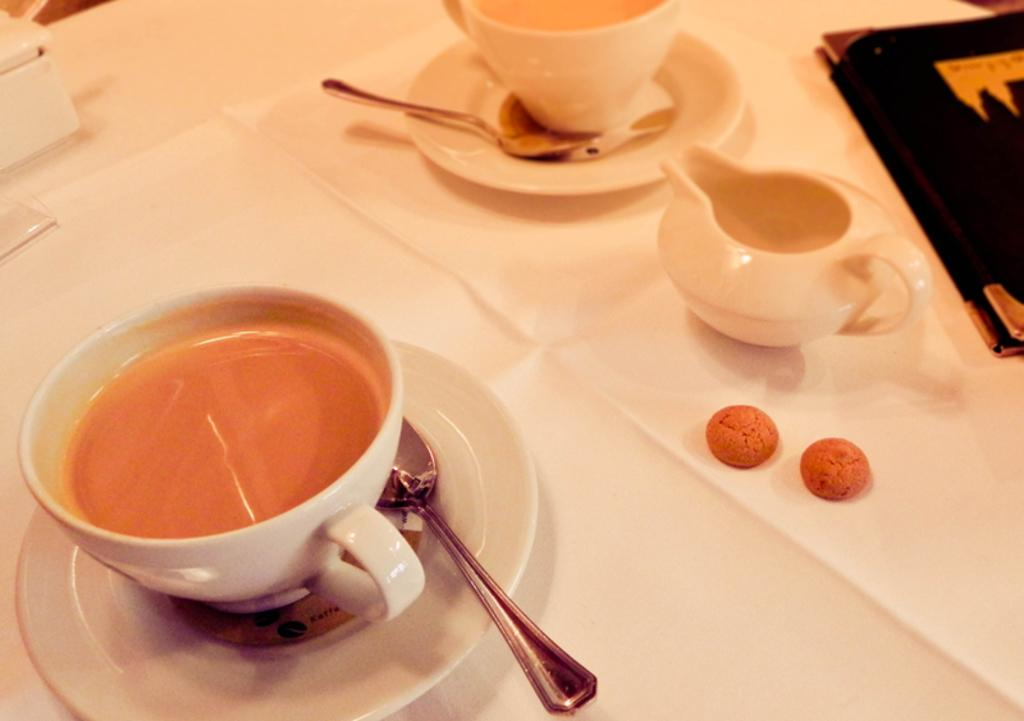What is located at the bottom of the image? There is a table at the bottom of the image. What items can be seen on the table? There are cups, saucers, spoons, biscuits, and a menu card on the table. What might be used for stirring or eating in the image? Spoons are on the table and can be used for stirring or eating. What type of food is present on the table? Biscuits are present on the table. What type of substance is being used to create the yoke in the image? There is no yoke present in the image, so it is not possible to determine what substance might be used to create it. 